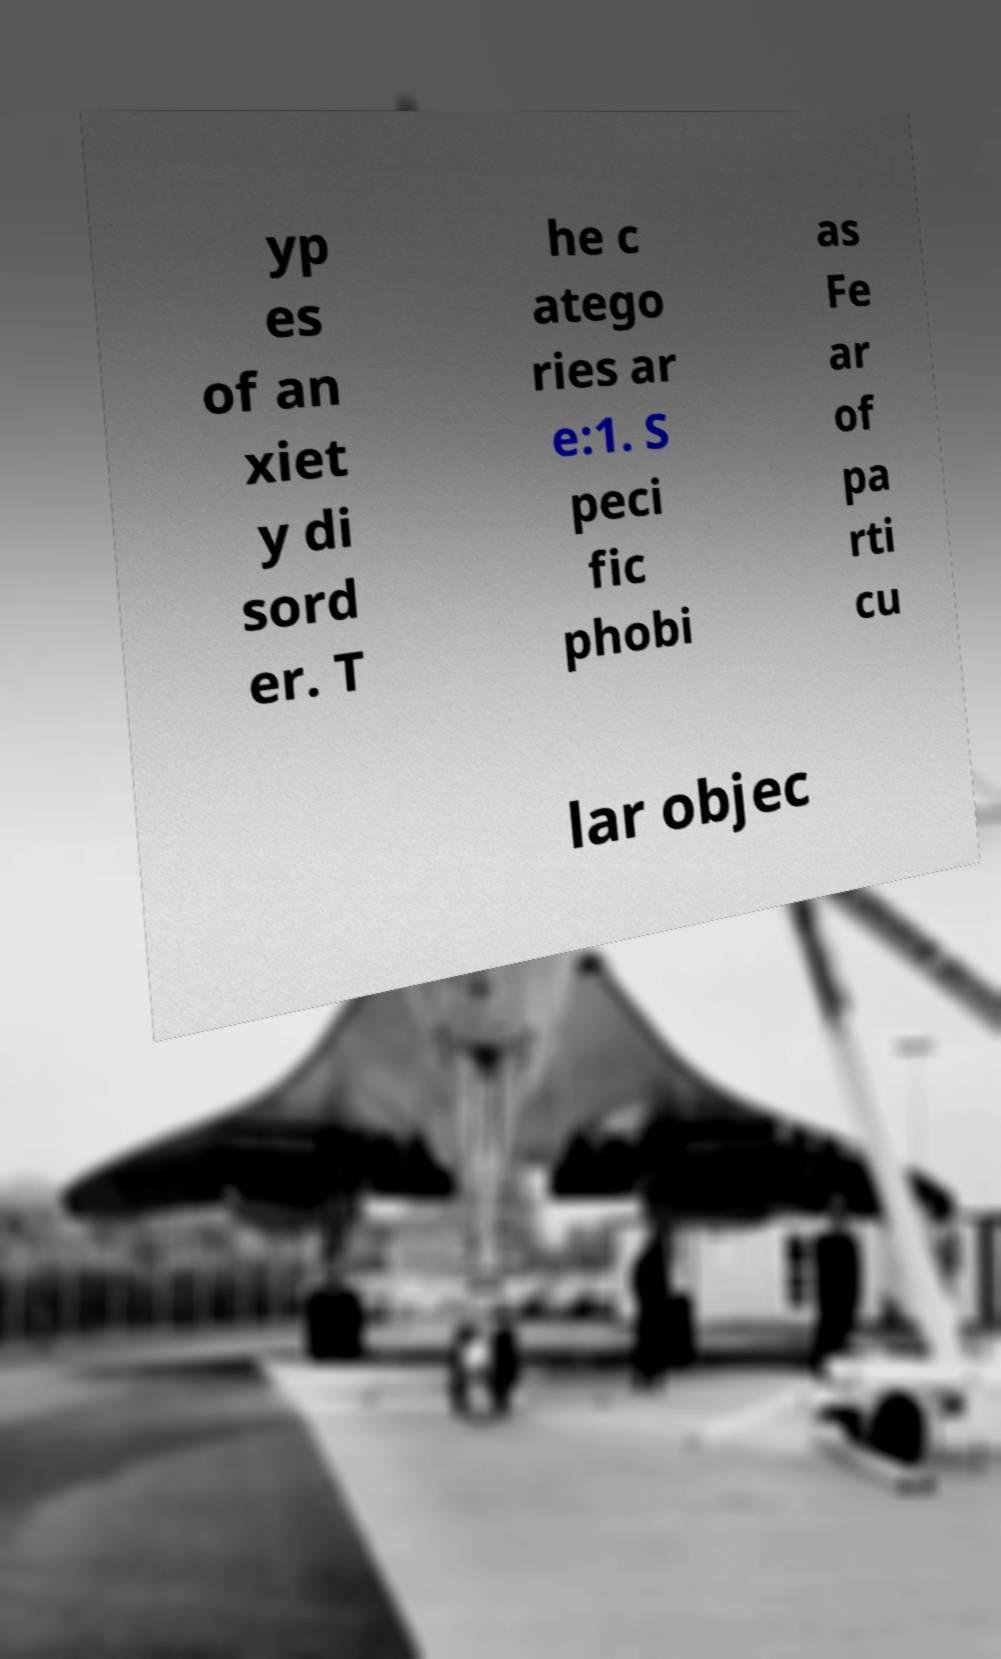I need the written content from this picture converted into text. Can you do that? yp es of an xiet y di sord er. T he c atego ries ar e:1. S peci fic phobi as Fe ar of pa rti cu lar objec 